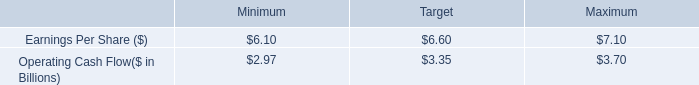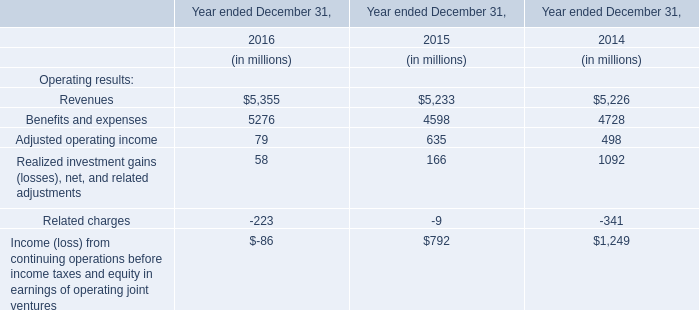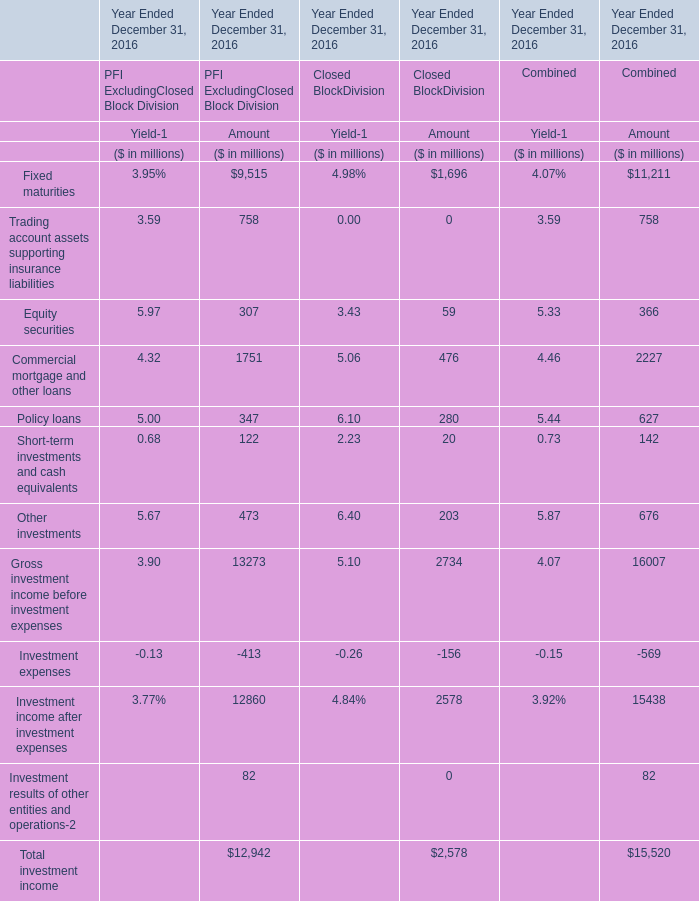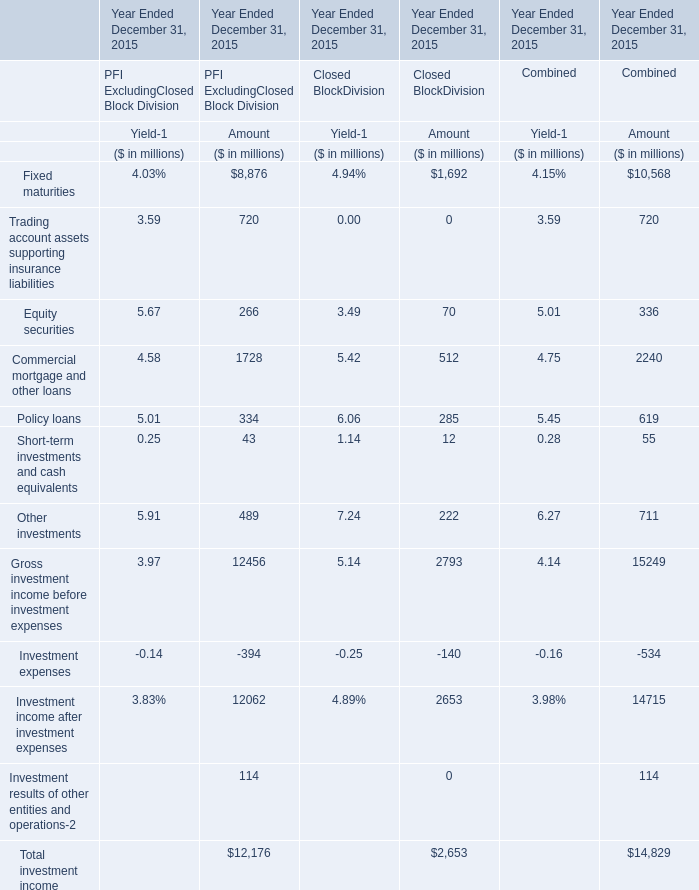what was the percent by which entergy corporation exceeded the reported earnings per share target in 2011 
Computations: (0.95 / 6.60)
Answer: 0.14394. 